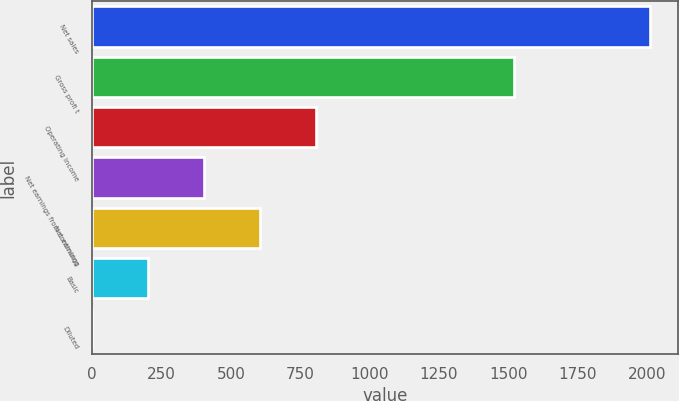Convert chart to OTSL. <chart><loc_0><loc_0><loc_500><loc_500><bar_chart><fcel>Net sales<fcel>Gross profi t<fcel>Operating income<fcel>Net earnings from continuing<fcel>Net earnings<fcel>Basic<fcel>Diluted<nl><fcel>2012.1<fcel>1521.5<fcel>805.21<fcel>402.91<fcel>604.06<fcel>201.76<fcel>0.61<nl></chart> 